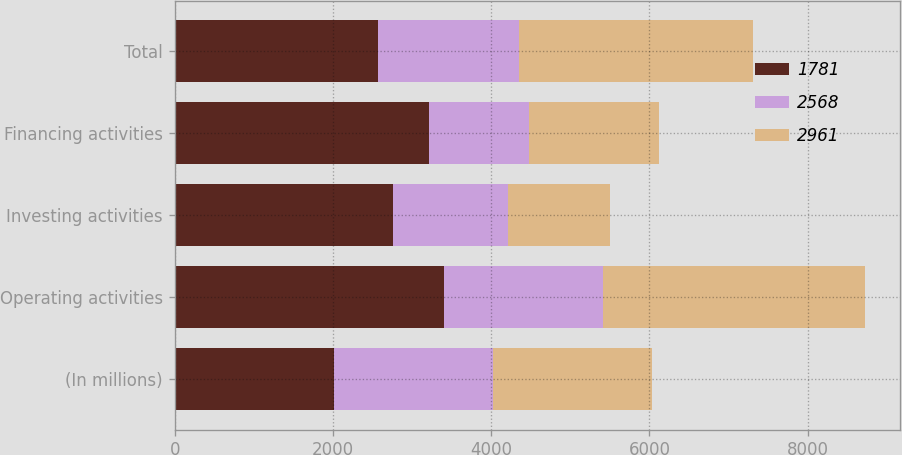Convert chart. <chart><loc_0><loc_0><loc_500><loc_500><stacked_bar_chart><ecel><fcel>(In millions)<fcel>Operating activities<fcel>Investing activities<fcel>Financing activities<fcel>Total<nl><fcel>1781<fcel>2013<fcel>3405<fcel>2756<fcel>3217<fcel>2568<nl><fcel>2568<fcel>2012<fcel>2012.5<fcel>1452<fcel>1259<fcel>1781<nl><fcel>2961<fcel>2011<fcel>3309<fcel>1295<fcel>1643<fcel>2961<nl></chart> 